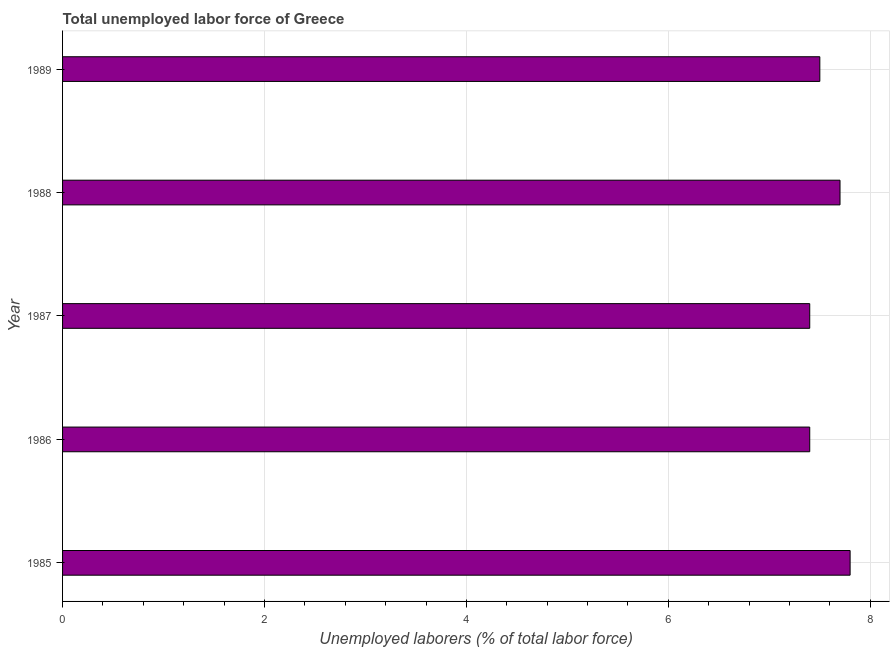Does the graph contain any zero values?
Ensure brevity in your answer.  No. Does the graph contain grids?
Your answer should be very brief. Yes. What is the title of the graph?
Offer a terse response. Total unemployed labor force of Greece. What is the label or title of the X-axis?
Ensure brevity in your answer.  Unemployed laborers (% of total labor force). What is the label or title of the Y-axis?
Keep it short and to the point. Year. What is the total unemployed labour force in 1987?
Offer a very short reply. 7.4. Across all years, what is the maximum total unemployed labour force?
Your answer should be very brief. 7.8. Across all years, what is the minimum total unemployed labour force?
Provide a succinct answer. 7.4. In which year was the total unemployed labour force maximum?
Make the answer very short. 1985. What is the sum of the total unemployed labour force?
Give a very brief answer. 37.8. What is the difference between the total unemployed labour force in 1986 and 1989?
Offer a very short reply. -0.1. What is the average total unemployed labour force per year?
Offer a terse response. 7.56. What is the median total unemployed labour force?
Make the answer very short. 7.5. In how many years, is the total unemployed labour force greater than 0.8 %?
Your answer should be compact. 5. What is the ratio of the total unemployed labour force in 1985 to that in 1989?
Provide a short and direct response. 1.04. Is the difference between the total unemployed labour force in 1985 and 1986 greater than the difference between any two years?
Keep it short and to the point. Yes. Is the sum of the total unemployed labour force in 1985 and 1987 greater than the maximum total unemployed labour force across all years?
Offer a terse response. Yes. How many bars are there?
Provide a succinct answer. 5. Are all the bars in the graph horizontal?
Offer a very short reply. Yes. Are the values on the major ticks of X-axis written in scientific E-notation?
Provide a short and direct response. No. What is the Unemployed laborers (% of total labor force) in 1985?
Offer a very short reply. 7.8. What is the Unemployed laborers (% of total labor force) of 1986?
Provide a succinct answer. 7.4. What is the Unemployed laborers (% of total labor force) of 1987?
Keep it short and to the point. 7.4. What is the Unemployed laborers (% of total labor force) of 1988?
Ensure brevity in your answer.  7.7. What is the Unemployed laborers (% of total labor force) in 1989?
Keep it short and to the point. 7.5. What is the difference between the Unemployed laborers (% of total labor force) in 1985 and 1986?
Your answer should be very brief. 0.4. What is the difference between the Unemployed laborers (% of total labor force) in 1985 and 1989?
Provide a succinct answer. 0.3. What is the difference between the Unemployed laborers (% of total labor force) in 1986 and 1987?
Your answer should be compact. 0. What is the difference between the Unemployed laborers (% of total labor force) in 1986 and 1988?
Your response must be concise. -0.3. What is the difference between the Unemployed laborers (% of total labor force) in 1986 and 1989?
Provide a succinct answer. -0.1. What is the difference between the Unemployed laborers (% of total labor force) in 1987 and 1988?
Your answer should be very brief. -0.3. What is the difference between the Unemployed laborers (% of total labor force) in 1987 and 1989?
Offer a very short reply. -0.1. What is the ratio of the Unemployed laborers (% of total labor force) in 1985 to that in 1986?
Offer a very short reply. 1.05. What is the ratio of the Unemployed laborers (% of total labor force) in 1985 to that in 1987?
Ensure brevity in your answer.  1.05. What is the ratio of the Unemployed laborers (% of total labor force) in 1985 to that in 1989?
Make the answer very short. 1.04. What is the ratio of the Unemployed laborers (% of total labor force) in 1986 to that in 1987?
Your answer should be very brief. 1. What is the ratio of the Unemployed laborers (% of total labor force) in 1986 to that in 1989?
Your answer should be very brief. 0.99. 